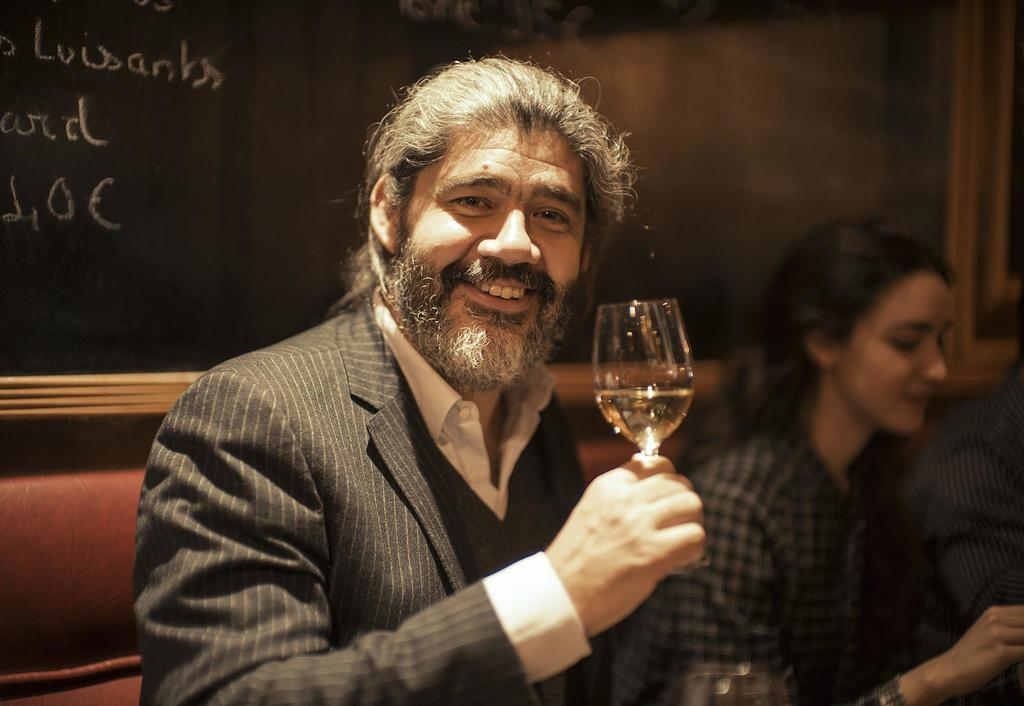What is the person in the image doing? The person is sitting on a chair in the image. What is the person's facial expression? The person is smiling. What is the person holding in their hand? The person is holding a wine glass in their hand. Who is sitting beside the person? There is a woman sitting beside the person. What type of slave is depicted in the image? There is no slave depicted in the image; it features a person sitting on a chair and holding a wine glass. What kind of club can be seen in the image? There is no club present in the image. 